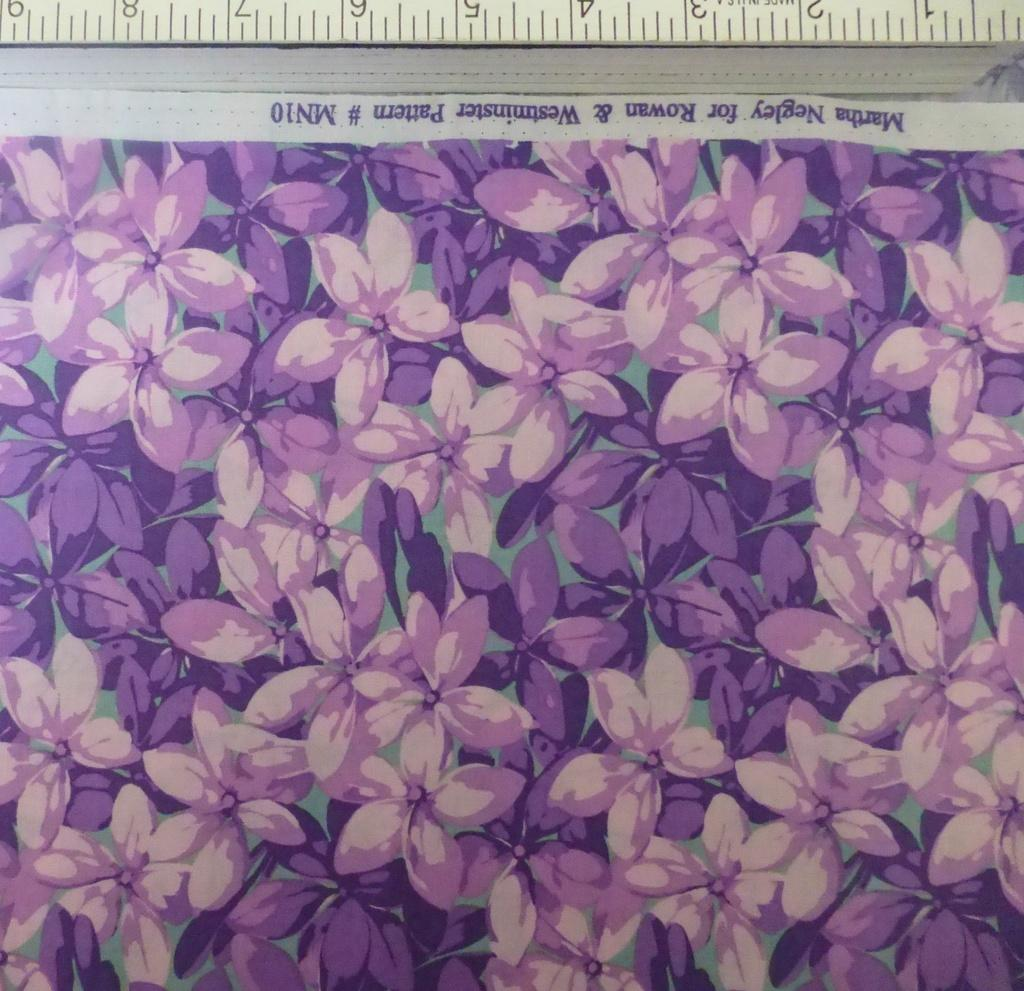<image>
Provide a brief description of the given image. A ruler is measuring nine inches of purple, floral, Martha Negley for Rowan & Wesuninster pattern. 